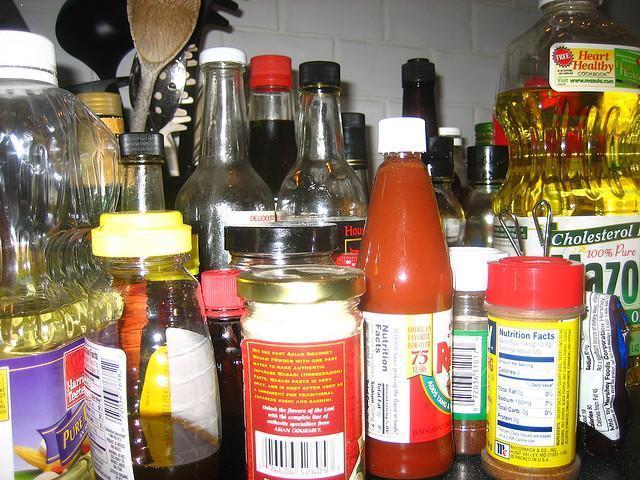How many spoons can you see?
Give a very brief answer. 2. How many bottles are visible?
Give a very brief answer. 11. 